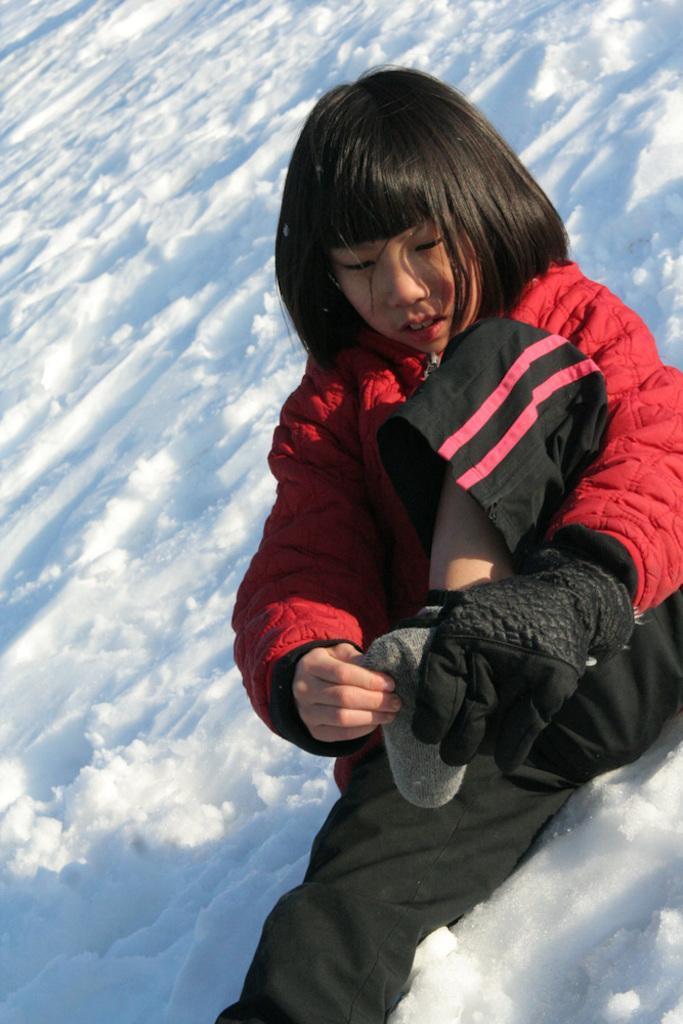How would you summarize this image in a sentence or two? This image consists of a girl wearing a red jacket and black gloves is sitting in the snow. At the bottom, there is snow. 